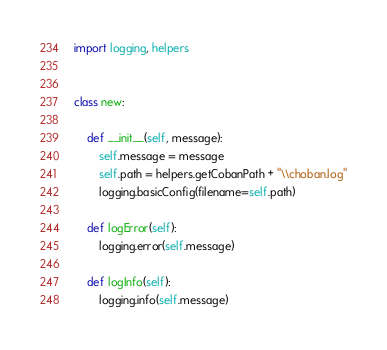Convert code to text. <code><loc_0><loc_0><loc_500><loc_500><_Python_>import logging, helpers


class new:

    def __init__(self, message):
        self.message = message
        self.path = helpers.getCobanPath + "\\choban.log"
        logging.basicConfig(filename=self.path)

    def logError(self):
        logging.error(self.message)

    def logInfo(self):
        logging.info(self.message)
</code> 